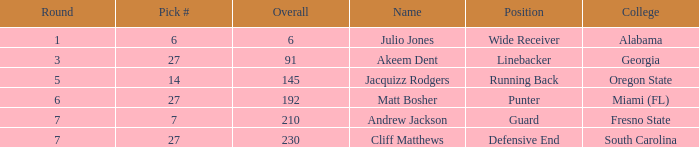Which overall's draft number was 14? 145.0. 